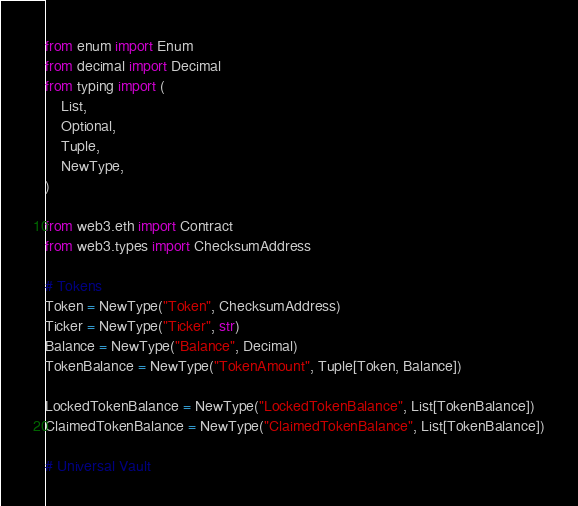<code> <loc_0><loc_0><loc_500><loc_500><_Python_>from enum import Enum
from decimal import Decimal
from typing import (
    List, 
    Optional, 
    Tuple,
    NewType,
)

from web3.eth import Contract
from web3.types import ChecksumAddress

# Tokens
Token = NewType("Token", ChecksumAddress)
Ticker = NewType("Ticker", str)
Balance = NewType("Balance", Decimal)
TokenBalance = NewType("TokenAmount", Tuple[Token, Balance])

LockedTokenBalance = NewType("LockedTokenBalance", List[TokenBalance])
ClaimedTokenBalance = NewType("ClaimedTokenBalance", List[TokenBalance])

# Universal Vault</code> 